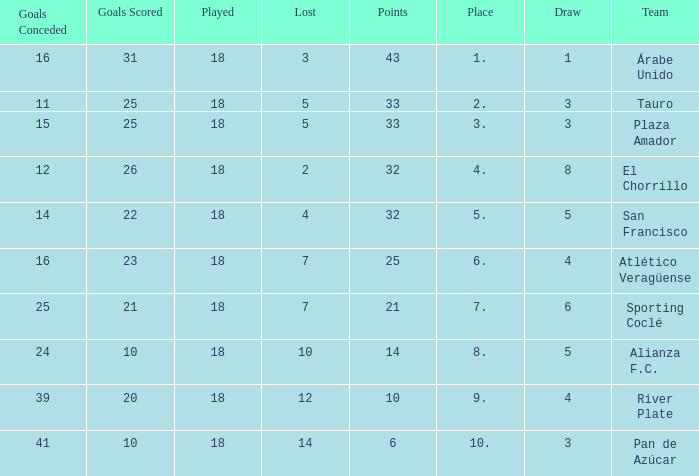How many goals were conceded by the team with more than 21 points more than 5 draws and less than 18 games played? None. 